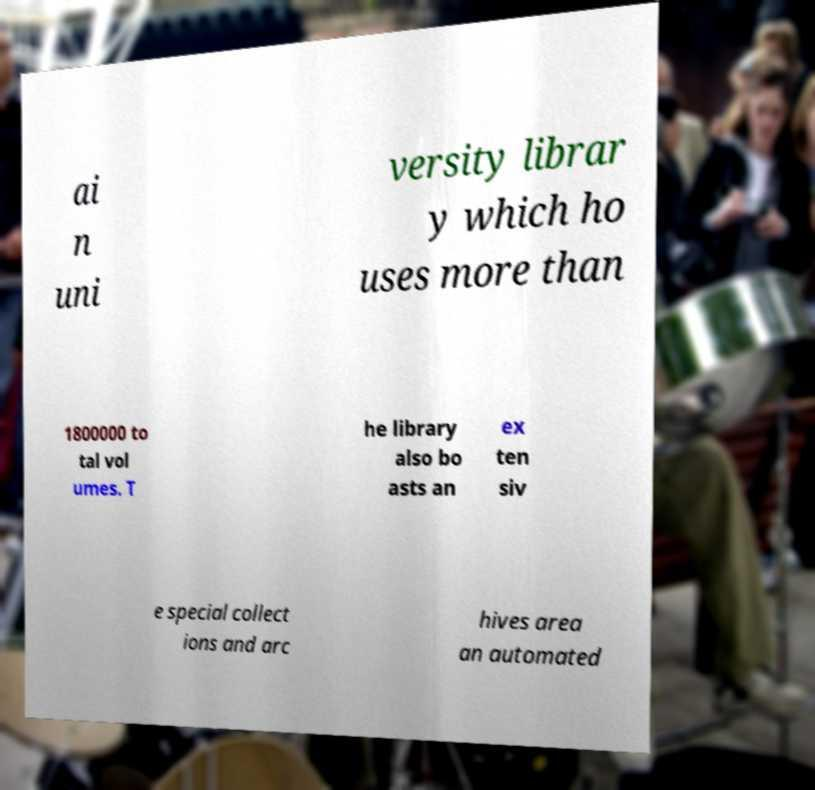Can you accurately transcribe the text from the provided image for me? ai n uni versity librar y which ho uses more than 1800000 to tal vol umes. T he library also bo asts an ex ten siv e special collect ions and arc hives area an automated 